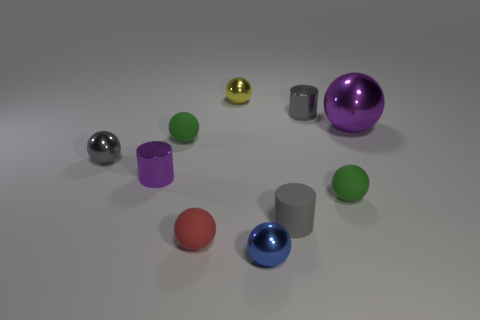Subtract all gray balls. How many balls are left? 6 Subtract all tiny green rubber balls. How many balls are left? 5 Subtract all yellow balls. Subtract all red blocks. How many balls are left? 6 Subtract all spheres. How many objects are left? 3 Add 8 green spheres. How many green spheres exist? 10 Subtract 1 blue spheres. How many objects are left? 9 Subtract all big metal things. Subtract all small gray things. How many objects are left? 6 Add 9 red spheres. How many red spheres are left? 10 